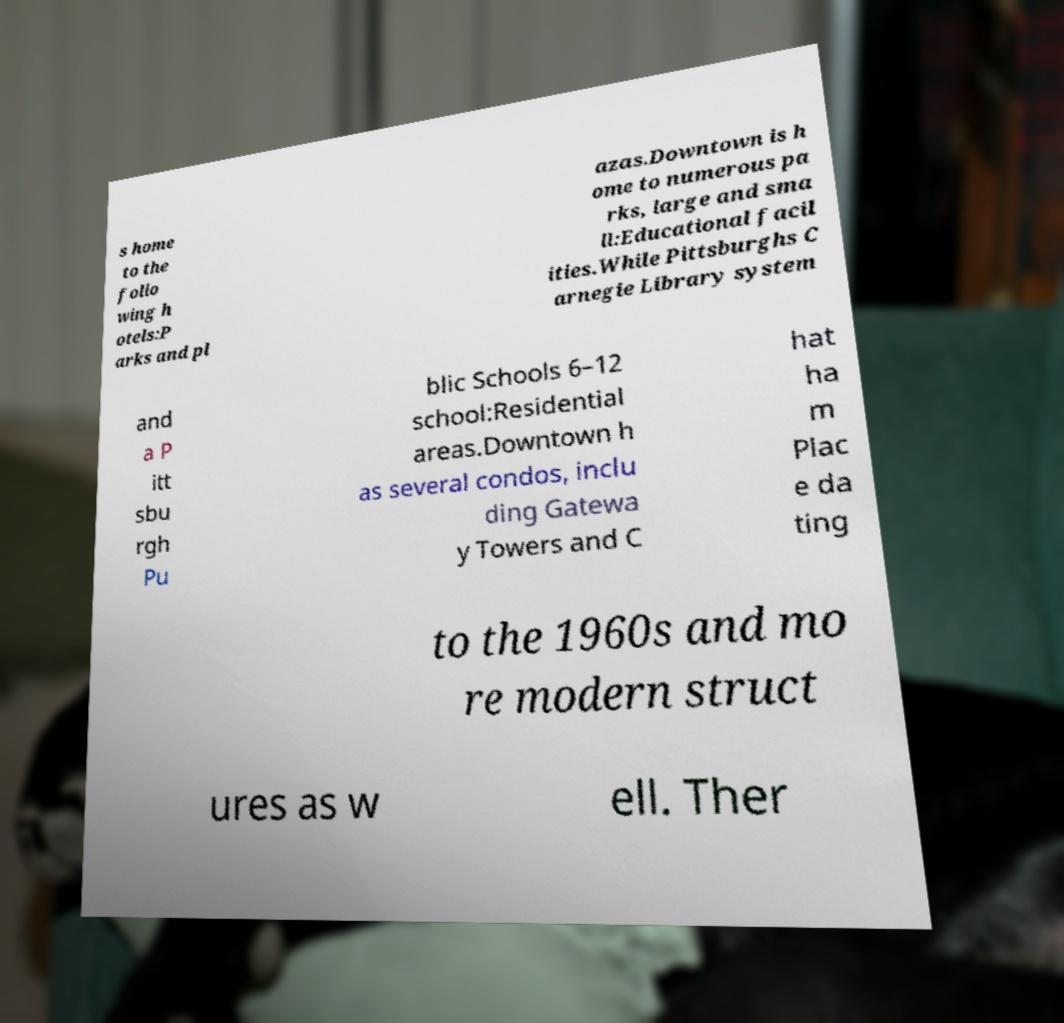I need the written content from this picture converted into text. Can you do that? s home to the follo wing h otels:P arks and pl azas.Downtown is h ome to numerous pa rks, large and sma ll:Educational facil ities.While Pittsburghs C arnegie Library system and a P itt sbu rgh Pu blic Schools 6–12 school:Residential areas.Downtown h as several condos, inclu ding Gatewa y Towers and C hat ha m Plac e da ting to the 1960s and mo re modern struct ures as w ell. Ther 